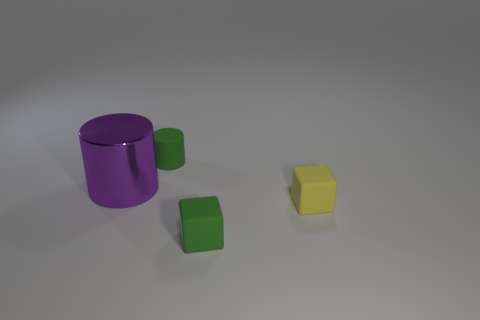Add 2 rubber objects. How many objects exist? 6 Subtract all purple cylinders. How many cylinders are left? 1 Add 2 small purple metallic cubes. How many small purple metallic cubes exist? 2 Subtract 0 green spheres. How many objects are left? 4 Subtract 1 cylinders. How many cylinders are left? 1 Subtract all gray cylinders. Subtract all cyan blocks. How many cylinders are left? 2 Subtract all blue rubber objects. Subtract all big purple objects. How many objects are left? 3 Add 2 small matte objects. How many small matte objects are left? 5 